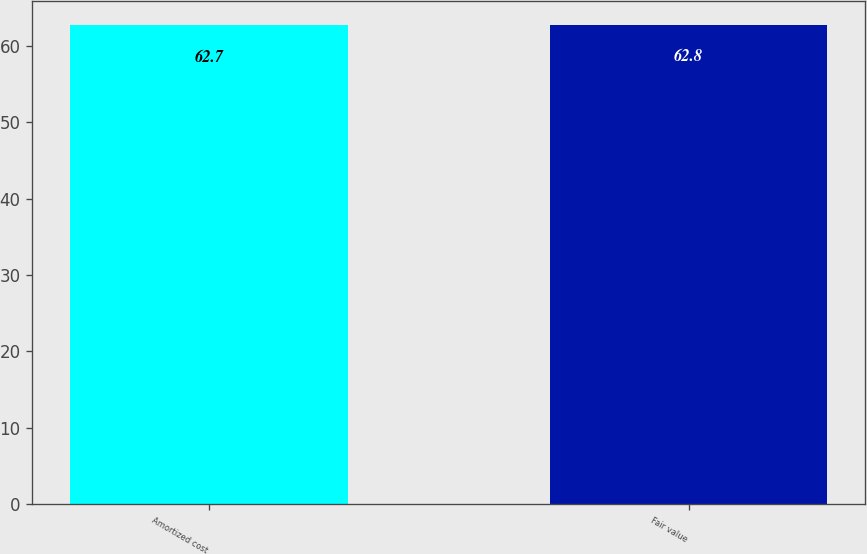<chart> <loc_0><loc_0><loc_500><loc_500><bar_chart><fcel>Amortized cost<fcel>Fair value<nl><fcel>62.7<fcel>62.8<nl></chart> 